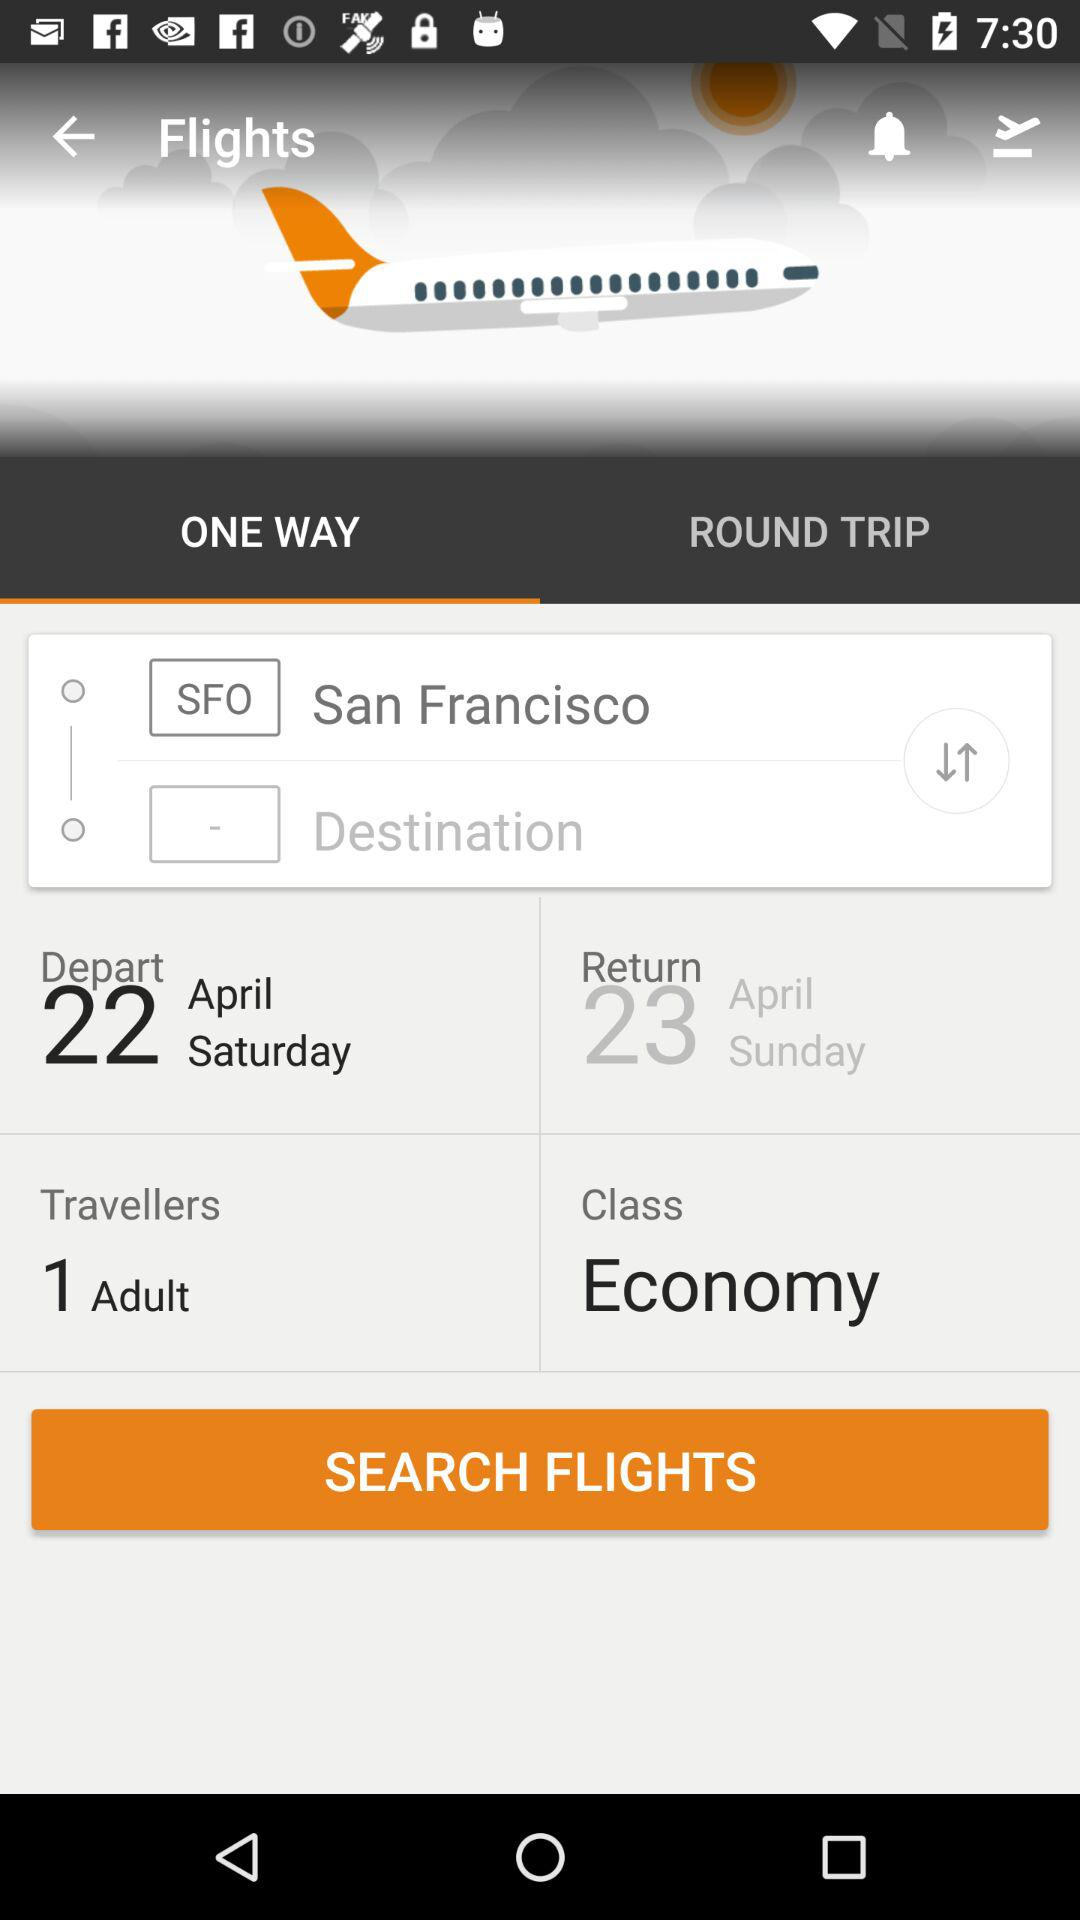How many travellers are included in this booking?
Answer the question using a single word or phrase. 1 